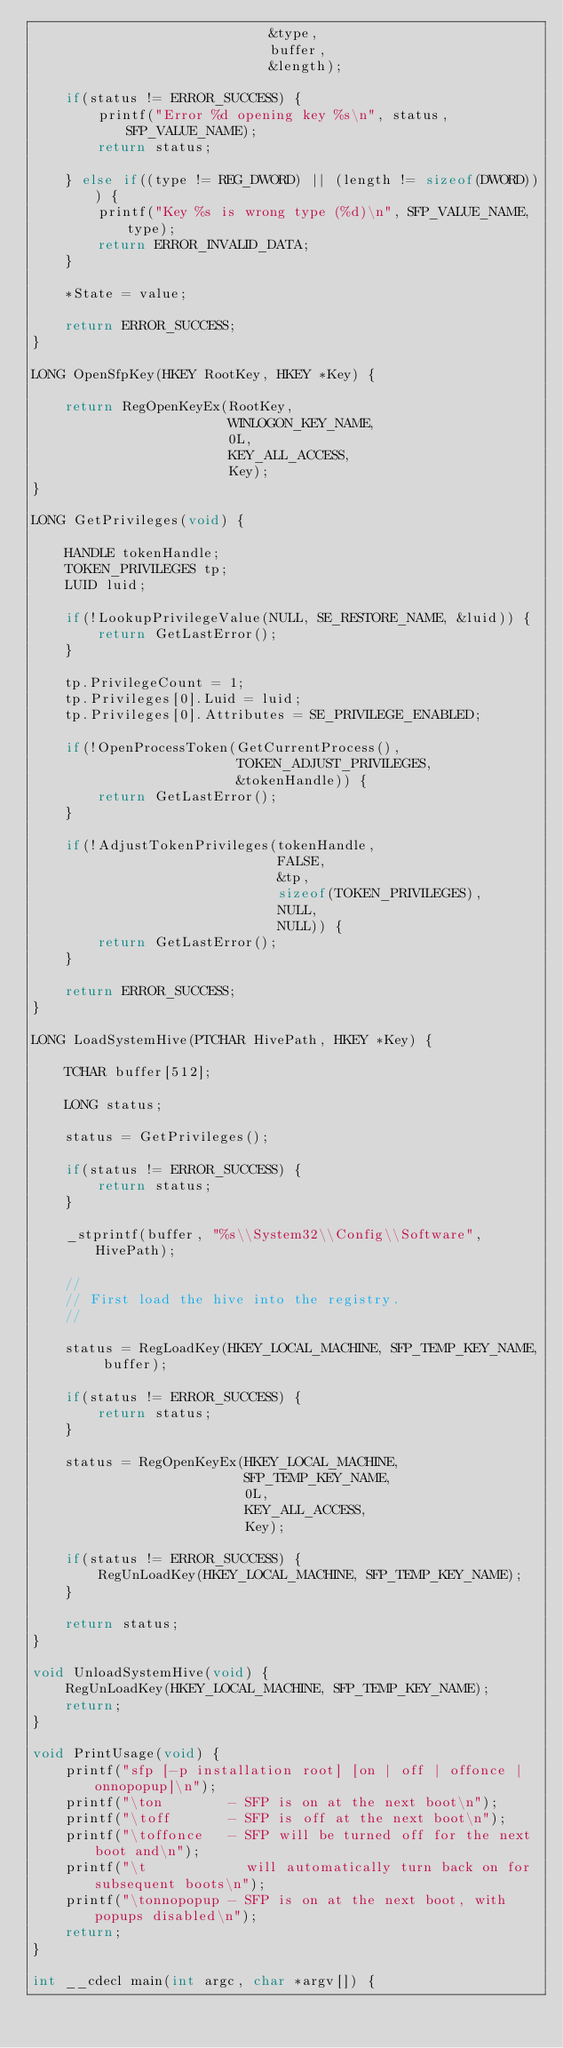Convert code to text. <code><loc_0><loc_0><loc_500><loc_500><_C_>                             &type,
                             buffer,
                             &length);

    if(status != ERROR_SUCCESS) {
        printf("Error %d opening key %s\n", status, SFP_VALUE_NAME);
        return status;

    } else if((type != REG_DWORD) || (length != sizeof(DWORD))) {
        printf("Key %s is wrong type (%d)\n", SFP_VALUE_NAME, type);
        return ERROR_INVALID_DATA;
    }

    *State = value;

    return ERROR_SUCCESS;
}

LONG OpenSfpKey(HKEY RootKey, HKEY *Key) {

    return RegOpenKeyEx(RootKey,
                        WINLOGON_KEY_NAME,
                        0L,
                        KEY_ALL_ACCESS,
                        Key);
}

LONG GetPrivileges(void) {
    
    HANDLE tokenHandle;
    TOKEN_PRIVILEGES tp;
    LUID luid;

    if(!LookupPrivilegeValue(NULL, SE_RESTORE_NAME, &luid)) {
        return GetLastError();
    }

    tp.PrivilegeCount = 1;
    tp.Privileges[0].Luid = luid;
    tp.Privileges[0].Attributes = SE_PRIVILEGE_ENABLED;

    if(!OpenProcessToken(GetCurrentProcess(), 
                         TOKEN_ADJUST_PRIVILEGES,
                         &tokenHandle)) {
        return GetLastError();
    }

    if(!AdjustTokenPrivileges(tokenHandle, 
                              FALSE, 
                              &tp,
                              sizeof(TOKEN_PRIVILEGES),
                              NULL,
                              NULL)) {
        return GetLastError();
    }

    return ERROR_SUCCESS;
}

LONG LoadSystemHive(PTCHAR HivePath, HKEY *Key) {

    TCHAR buffer[512];

    LONG status;

    status = GetPrivileges();

    if(status != ERROR_SUCCESS) {
        return status;
    }

    _stprintf(buffer, "%s\\System32\\Config\\Software", HivePath);

    //
    // First load the hive into the registry.
    //

    status = RegLoadKey(HKEY_LOCAL_MACHINE, SFP_TEMP_KEY_NAME, buffer);

    if(status != ERROR_SUCCESS) {
        return status;
    }

    status = RegOpenKeyEx(HKEY_LOCAL_MACHINE, 
                          SFP_TEMP_KEY_NAME,
                          0L,
                          KEY_ALL_ACCESS,
                          Key);

    if(status != ERROR_SUCCESS) {
        RegUnLoadKey(HKEY_LOCAL_MACHINE, SFP_TEMP_KEY_NAME);
    }

    return status;
}

void UnloadSystemHive(void) {
    RegUnLoadKey(HKEY_LOCAL_MACHINE, SFP_TEMP_KEY_NAME);
    return;
}

void PrintUsage(void) {
    printf("sfp [-p installation root] [on | off | offonce | onnopopup]\n");
    printf("\ton        - SFP is on at the next boot\n");
    printf("\toff       - SFP is off at the next boot\n");
    printf("\toffonce   - SFP will be turned off for the next boot and\n");
    printf("\t            will automatically turn back on for subsequent boots\n");
    printf("\tonnopopup - SFP is on at the next boot, with popups disabled\n");
    return;
}

int __cdecl main(int argc, char *argv[]) {</code> 